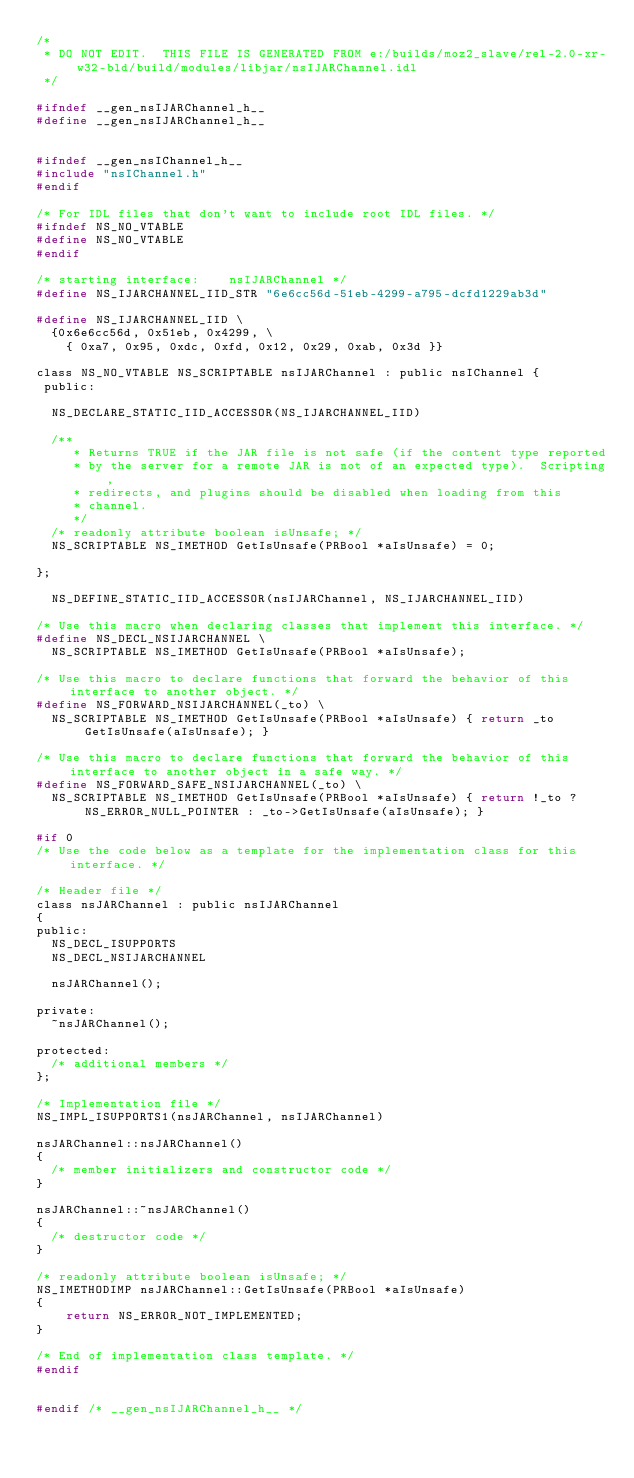Convert code to text. <code><loc_0><loc_0><loc_500><loc_500><_C_>/*
 * DO NOT EDIT.  THIS FILE IS GENERATED FROM e:/builds/moz2_slave/rel-2.0-xr-w32-bld/build/modules/libjar/nsIJARChannel.idl
 */

#ifndef __gen_nsIJARChannel_h__
#define __gen_nsIJARChannel_h__


#ifndef __gen_nsIChannel_h__
#include "nsIChannel.h"
#endif

/* For IDL files that don't want to include root IDL files. */
#ifndef NS_NO_VTABLE
#define NS_NO_VTABLE
#endif

/* starting interface:    nsIJARChannel */
#define NS_IJARCHANNEL_IID_STR "6e6cc56d-51eb-4299-a795-dcfd1229ab3d"

#define NS_IJARCHANNEL_IID \
  {0x6e6cc56d, 0x51eb, 0x4299, \
    { 0xa7, 0x95, 0xdc, 0xfd, 0x12, 0x29, 0xab, 0x3d }}

class NS_NO_VTABLE NS_SCRIPTABLE nsIJARChannel : public nsIChannel {
 public: 

  NS_DECLARE_STATIC_IID_ACCESSOR(NS_IJARCHANNEL_IID)

  /**
     * Returns TRUE if the JAR file is not safe (if the content type reported
     * by the server for a remote JAR is not of an expected type).  Scripting,
     * redirects, and plugins should be disabled when loading from this
     * channel.
     */
  /* readonly attribute boolean isUnsafe; */
  NS_SCRIPTABLE NS_IMETHOD GetIsUnsafe(PRBool *aIsUnsafe) = 0;

};

  NS_DEFINE_STATIC_IID_ACCESSOR(nsIJARChannel, NS_IJARCHANNEL_IID)

/* Use this macro when declaring classes that implement this interface. */
#define NS_DECL_NSIJARCHANNEL \
  NS_SCRIPTABLE NS_IMETHOD GetIsUnsafe(PRBool *aIsUnsafe); 

/* Use this macro to declare functions that forward the behavior of this interface to another object. */
#define NS_FORWARD_NSIJARCHANNEL(_to) \
  NS_SCRIPTABLE NS_IMETHOD GetIsUnsafe(PRBool *aIsUnsafe) { return _to GetIsUnsafe(aIsUnsafe); } 

/* Use this macro to declare functions that forward the behavior of this interface to another object in a safe way. */
#define NS_FORWARD_SAFE_NSIJARCHANNEL(_to) \
  NS_SCRIPTABLE NS_IMETHOD GetIsUnsafe(PRBool *aIsUnsafe) { return !_to ? NS_ERROR_NULL_POINTER : _to->GetIsUnsafe(aIsUnsafe); } 

#if 0
/* Use the code below as a template for the implementation class for this interface. */

/* Header file */
class nsJARChannel : public nsIJARChannel
{
public:
  NS_DECL_ISUPPORTS
  NS_DECL_NSIJARCHANNEL

  nsJARChannel();

private:
  ~nsJARChannel();

protected:
  /* additional members */
};

/* Implementation file */
NS_IMPL_ISUPPORTS1(nsJARChannel, nsIJARChannel)

nsJARChannel::nsJARChannel()
{
  /* member initializers and constructor code */
}

nsJARChannel::~nsJARChannel()
{
  /* destructor code */
}

/* readonly attribute boolean isUnsafe; */
NS_IMETHODIMP nsJARChannel::GetIsUnsafe(PRBool *aIsUnsafe)
{
    return NS_ERROR_NOT_IMPLEMENTED;
}

/* End of implementation class template. */
#endif


#endif /* __gen_nsIJARChannel_h__ */
</code> 